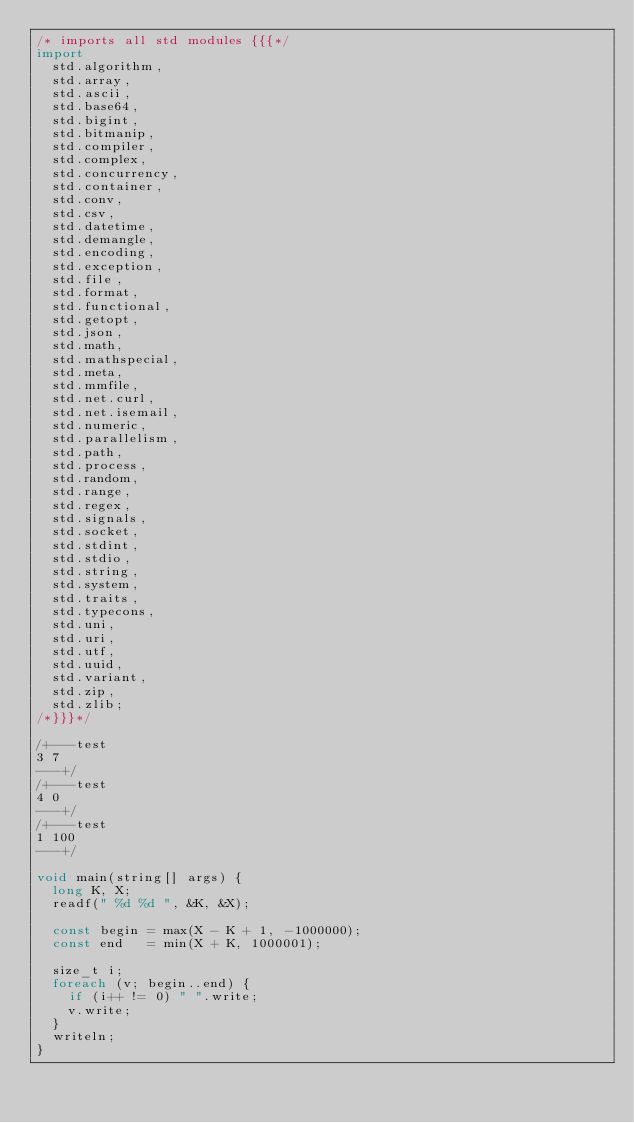Convert code to text. <code><loc_0><loc_0><loc_500><loc_500><_D_>/* imports all std modules {{{*/
import
  std.algorithm,
  std.array,
  std.ascii,
  std.base64,
  std.bigint,
  std.bitmanip,
  std.compiler,
  std.complex,
  std.concurrency,
  std.container,
  std.conv,
  std.csv,
  std.datetime,
  std.demangle,
  std.encoding,
  std.exception,
  std.file,
  std.format,
  std.functional,
  std.getopt,
  std.json,
  std.math,
  std.mathspecial,
  std.meta,
  std.mmfile,
  std.net.curl,
  std.net.isemail,
  std.numeric,
  std.parallelism,
  std.path,
  std.process,
  std.random,
  std.range,
  std.regex,
  std.signals,
  std.socket,
  std.stdint,
  std.stdio,
  std.string,
  std.system,
  std.traits,
  std.typecons,
  std.uni,
  std.uri,
  std.utf,
  std.uuid,
  std.variant,
  std.zip,
  std.zlib;
/*}}}*/

/+---test
3 7
---+/
/+---test
4 0
---+/
/+---test
1 100
---+/

void main(string[] args) {
  long K, X;
  readf(" %d %d ", &K, &X);

  const begin = max(X - K + 1, -1000000);
  const end   = min(X + K, 1000001);

  size_t i;
  foreach (v; begin..end) {
    if (i++ != 0) " ".write;
    v.write;
  }
  writeln;
}
</code> 